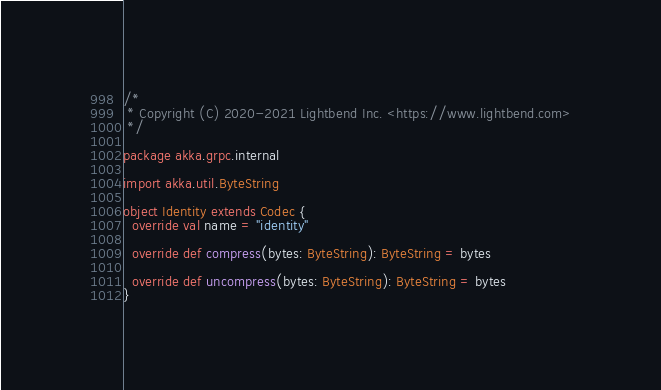Convert code to text. <code><loc_0><loc_0><loc_500><loc_500><_Scala_>/*
 * Copyright (C) 2020-2021 Lightbend Inc. <https://www.lightbend.com>
 */

package akka.grpc.internal

import akka.util.ByteString

object Identity extends Codec {
  override val name = "identity"

  override def compress(bytes: ByteString): ByteString = bytes

  override def uncompress(bytes: ByteString): ByteString = bytes
}
</code> 